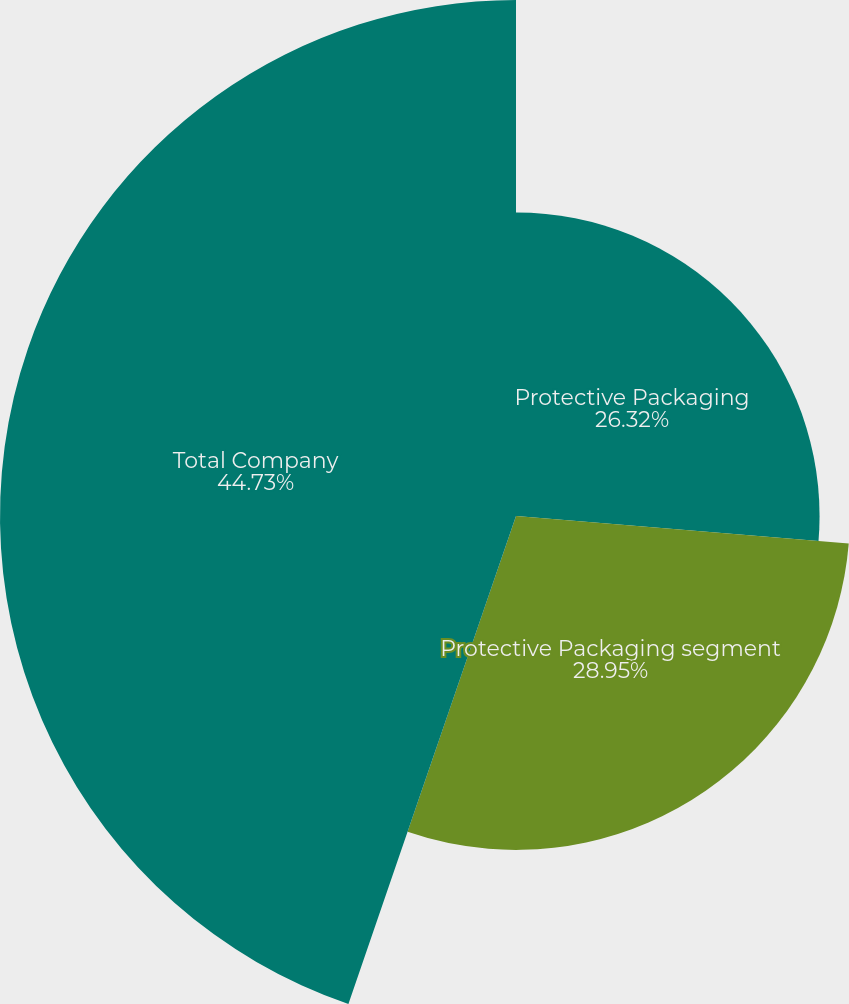<chart> <loc_0><loc_0><loc_500><loc_500><pie_chart><fcel>Protective Packaging<fcel>Protective Packaging segment<fcel>Total Company<nl><fcel>26.32%<fcel>28.95%<fcel>44.74%<nl></chart> 